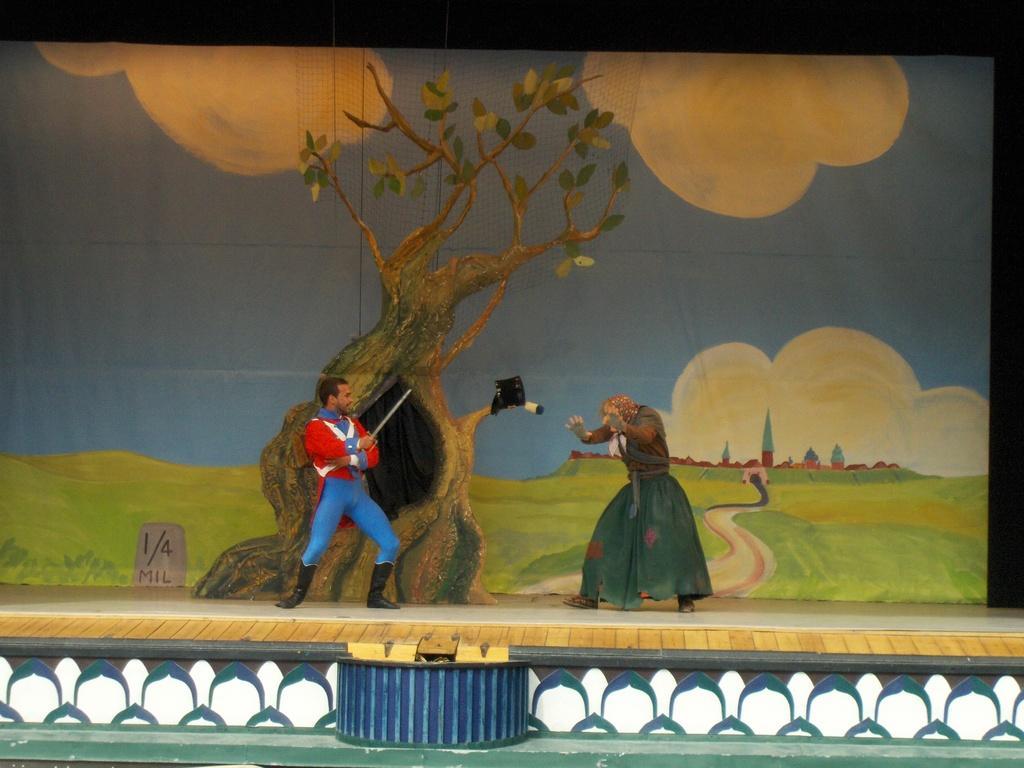Can you describe this image briefly? There are two persons showing a performance on a stage. In the background, there is a painting in which, there is a tree on the ground, there is a road, there is grass, there are trees and there are clouds in the blue sky. 